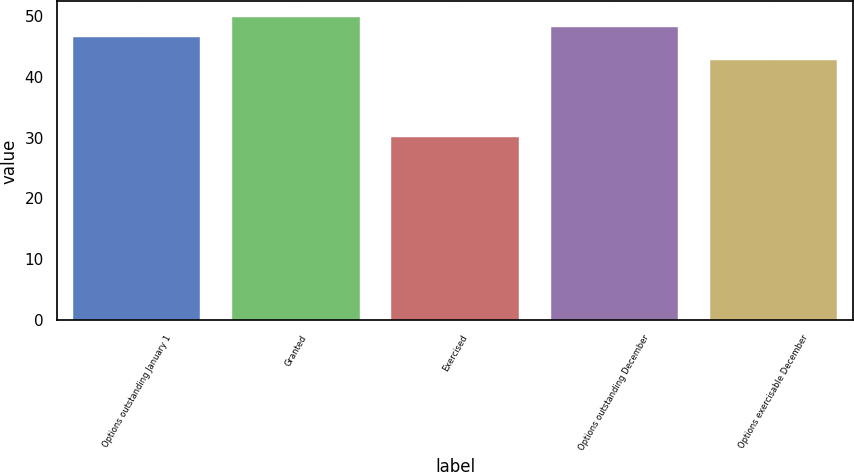<chart> <loc_0><loc_0><loc_500><loc_500><bar_chart><fcel>Options outstanding January 1<fcel>Granted<fcel>Exercised<fcel>Options outstanding December<fcel>Options exercisable December<nl><fcel>46.53<fcel>49.85<fcel>30.14<fcel>48.19<fcel>42.66<nl></chart> 